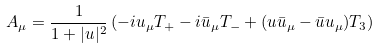<formula> <loc_0><loc_0><loc_500><loc_500>A _ { \mu } = \frac { 1 } { 1 + | u | ^ { 2 } } \left ( - i u _ { \mu } T _ { + } - i \bar { u } _ { \mu } T _ { - } + ( u \bar { u } _ { \mu } - \bar { u } u _ { \mu } ) T _ { 3 } \right )</formula> 